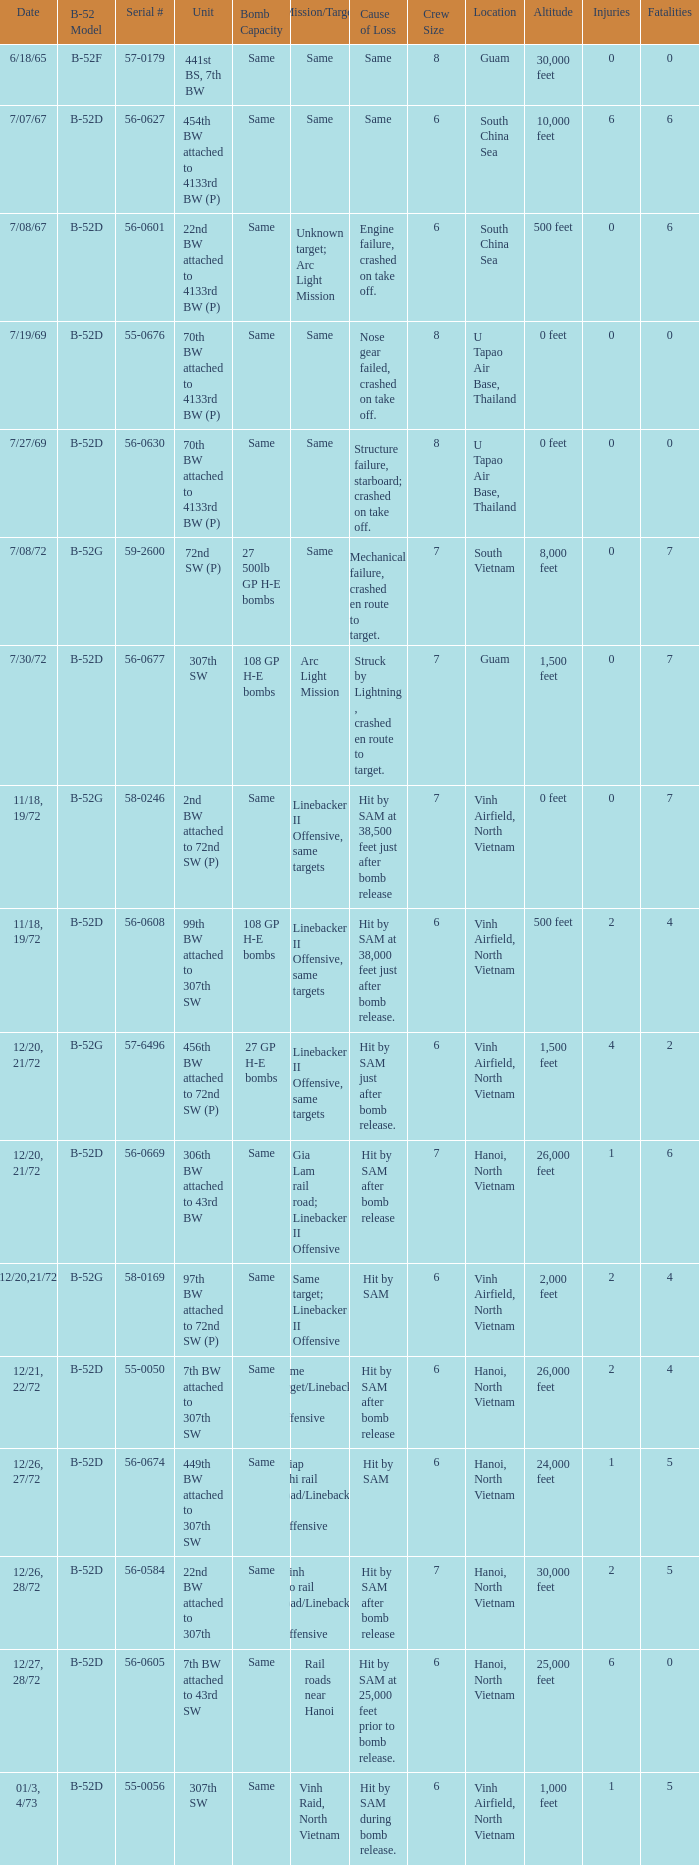When 7th bw attached to 43rd sw is the unit what is the b-52 model? B-52D. 